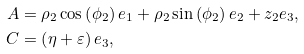Convert formula to latex. <formula><loc_0><loc_0><loc_500><loc_500>A & = \rho _ { 2 } \cos \left ( \phi _ { 2 } \right ) e _ { 1 } + \rho _ { 2 } \sin \left ( \phi _ { 2 } \right ) e _ { 2 } + z _ { 2 } e _ { 3 } , \\ C & = \left ( \eta + \varepsilon \right ) e _ { 3 } ,</formula> 